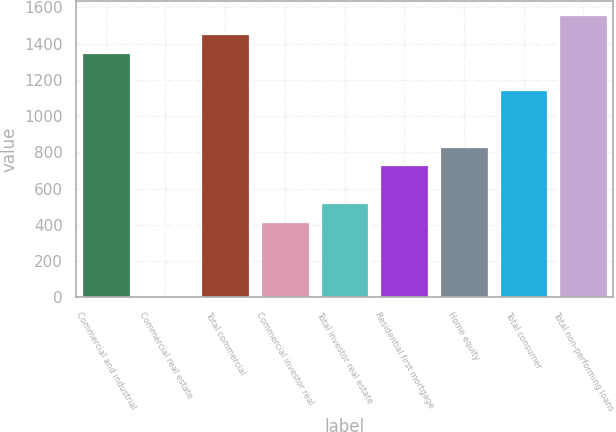Convert chart. <chart><loc_0><loc_0><loc_500><loc_500><bar_chart><fcel>Commercial and industrial<fcel>Commercial real estate<fcel>Total commercial<fcel>Commercial investor real<fcel>Total investor real estate<fcel>Residential first mortgage<fcel>Home equity<fcel>Total consumer<fcel>Total non-performing loans<nl><fcel>1350.1<fcel>2<fcel>1453.8<fcel>416.8<fcel>520.5<fcel>727.9<fcel>831.6<fcel>1142.7<fcel>1557.5<nl></chart> 